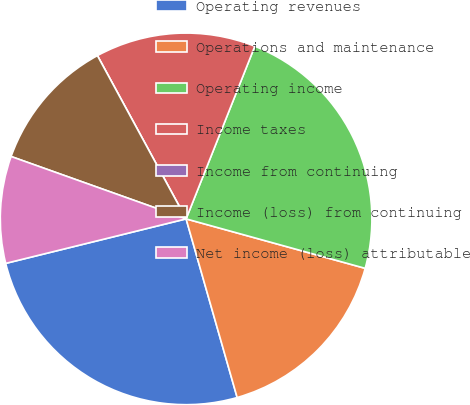Convert chart. <chart><loc_0><loc_0><loc_500><loc_500><pie_chart><fcel>Operating revenues<fcel>Operations and maintenance<fcel>Operating income<fcel>Income taxes<fcel>Income from continuing<fcel>Income (loss) from continuing<fcel>Net income (loss) attributable<nl><fcel>25.58%<fcel>16.28%<fcel>23.26%<fcel>13.95%<fcel>0.0%<fcel>11.63%<fcel>9.3%<nl></chart> 